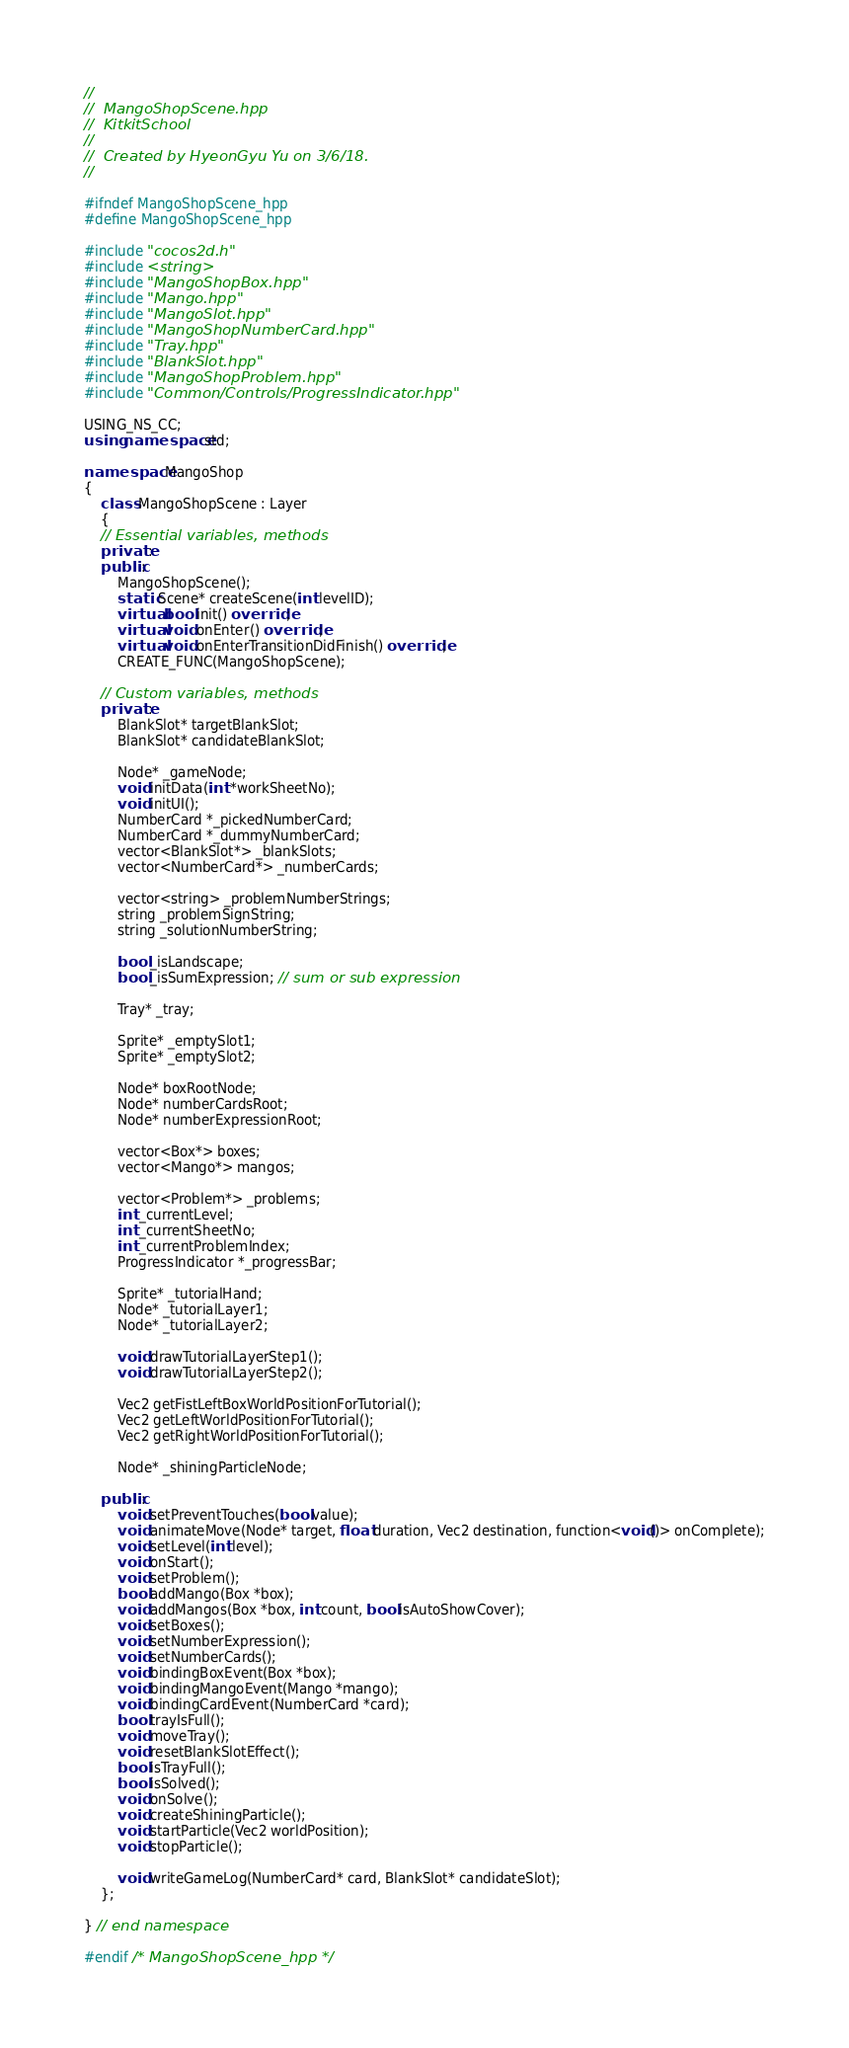Convert code to text. <code><loc_0><loc_0><loc_500><loc_500><_C++_>//
//  MangoShopScene.hpp
//  KitkitSchool
//
//  Created by HyeonGyu Yu on 3/6/18.
//

#ifndef MangoShopScene_hpp
#define MangoShopScene_hpp

#include "cocos2d.h"
#include <string>
#include "MangoShopBox.hpp"
#include "Mango.hpp"
#include "MangoSlot.hpp"
#include "MangoShopNumberCard.hpp"
#include "Tray.hpp"
#include "BlankSlot.hpp"
#include "MangoShopProblem.hpp"
#include "Common/Controls/ProgressIndicator.hpp"

USING_NS_CC;
using namespace std;

namespace MangoShop
{
    class MangoShopScene : Layer
    {
    // Essential variables, methods
    private:
    public:
        MangoShopScene();
        static Scene* createScene(int levelID);
        virtual bool init() override;
        virtual void onEnter() override;
        virtual void onEnterTransitionDidFinish() override;
        CREATE_FUNC(MangoShopScene);
        
    // Custom variables, methods
    private:
        BlankSlot* targetBlankSlot;
        BlankSlot* candidateBlankSlot;
        
        Node* _gameNode;
        void initData(int *workSheetNo);
        void initUI();
        NumberCard *_pickedNumberCard;
        NumberCard *_dummyNumberCard;
        vector<BlankSlot*> _blankSlots;
        vector<NumberCard*> _numberCards;
        
        vector<string> _problemNumberStrings;
        string _problemSignString;
        string _solutionNumberString;
        
        bool _isLandscape;
        bool _isSumExpression; // sum or sub expression
        
        Tray* _tray;
        
        Sprite* _emptySlot1;
        Sprite* _emptySlot2;

        Node* boxRootNode;
        Node* numberCardsRoot;
        Node* numberExpressionRoot;
        
        vector<Box*> boxes;
        vector<Mango*> mangos;

        vector<Problem*> _problems;
        int _currentLevel;
        int _currentSheetNo;
        int _currentProblemIndex;
        ProgressIndicator *_progressBar;
        
        Sprite* _tutorialHand;
        Node* _tutorialLayer1;
        Node* _tutorialLayer2;
        
        void drawTutorialLayerStep1();
        void drawTutorialLayerStep2();
        
        Vec2 getFistLeftBoxWorldPositionForTutorial();
        Vec2 getLeftWorldPositionForTutorial();
        Vec2 getRightWorldPositionForTutorial();
        
        Node* _shiningParticleNode;
        
    public:
        void setPreventTouches(bool value);
        void animateMove(Node* target, float duration, Vec2 destination, function<void()> onComplete);
        void setLevel(int level);
        void onStart();
        void setProblem();
        bool addMango(Box *box);
        void addMangos(Box *box, int count, bool isAutoShowCover);
        void setBoxes();
        void setNumberExpression();
        void setNumberCards();
        void bindingBoxEvent(Box *box);
        void bindingMangoEvent(Mango *mango);
        void bindingCardEvent(NumberCard *card);
        bool trayIsFull();
        void moveTray();
        void resetBlankSlotEffect();
        bool isTrayFull();
        bool isSolved();
        void onSolve();
        void createShiningParticle();
        void startParticle(Vec2 worldPosition);
        void stopParticle();
        
        void writeGameLog(NumberCard* card, BlankSlot* candidateSlot);
    };

} // end namespace

#endif /* MangoShopScene_hpp */
</code> 